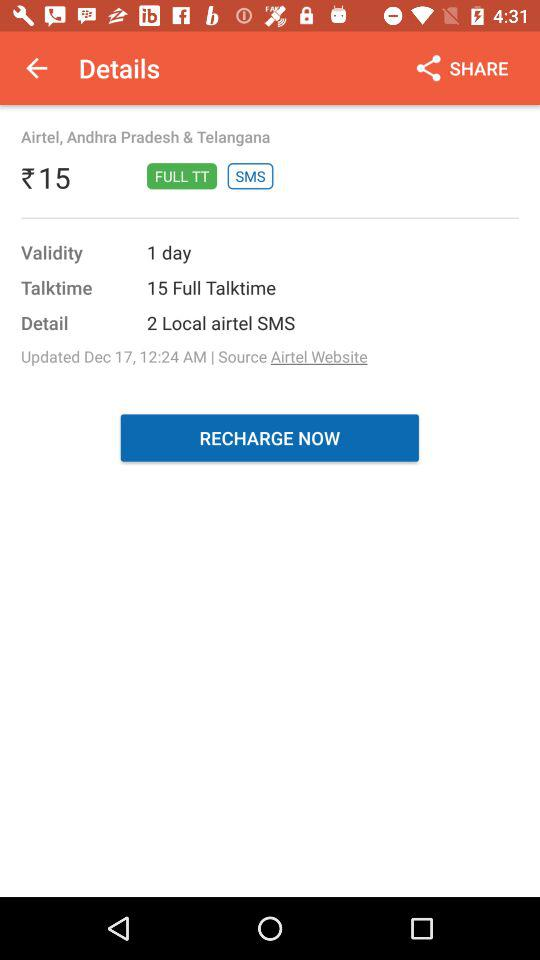What is the count of local Airtel SMS? The count of local Airtel SMS is 2. 